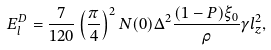<formula> <loc_0><loc_0><loc_500><loc_500>E _ { l } ^ { D } = \frac { 7 } { 1 2 0 } \left ( \frac { \pi } { 4 } \right ) ^ { 2 } N ( 0 ) \Delta ^ { 2 } \frac { ( 1 - P ) \xi _ { 0 } } { \rho } \gamma l _ { z } ^ { 2 } ,</formula> 